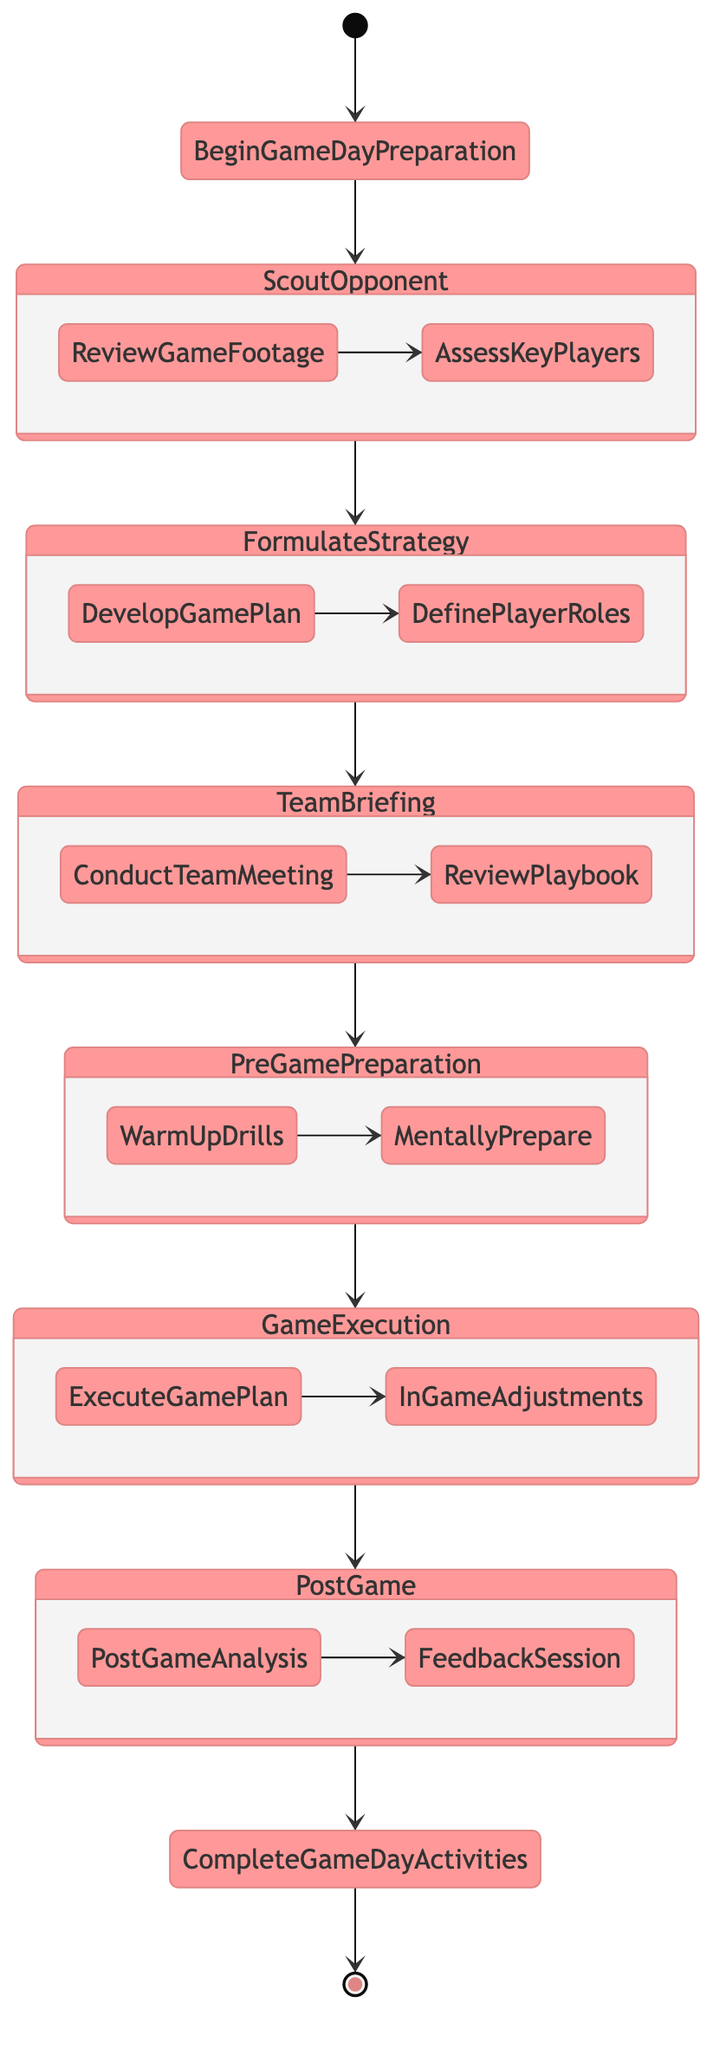What is the first stage of the game day preparation? The diagram starts with the node labeled "Begin Game Day Preparation," which indicates the first stage of the workflow. Thus, the first stage that follows is "Scout Opponent."
Answer: Scout Opponent How many preparation stages are there in total? The diagram outlines four preparation stages: "Scout Opponent," "Formulate Strategy," "Team Briefing," and "Pre-game Preparation." Counting these, we find there are a total of four stages.
Answer: 4 What step comes after "Review Game Footage"? Following the "Review Game Footage" step within the "Scout Opponent" state, the diagram leads to the next step labeled "Assess Key Players." Therefore, this step directly follows it.
Answer: Assess Key Players What is the final activity listed in the post-game section? In the "Post Game" section of the diagram, the last activity before completing all game day activities is "Feedback Session." Hence, this is the final activity.
Answer: Feedback Session What are the two main activities in the Game Execution phase? The "Game Execution" phase contains two key activities as per the diagram: "Execute Game Plan" and "In-Game Adjustments." Both are critical actions within this phase.
Answer: Execute Game Plan, In-Game Adjustments What is the main purpose of the "Team Briefing" stage? The "Team Briefing" stage consists of discussing the game plan and ensuring all players understand the strategies. The goal is to prepare the team collectively, making sure everyone is aligned.
Answer: Discuss game plan and review strategies At which point does the game day preparation transition to the game execution? The transition from preparation to game execution occurs after the "Pre-game Preparation" stage ends, leading directly to the "Game Execution" phase in the diagram.
Answer: After Pre-game Preparation What happens after the "Feedback Session"? The activity that follows the "Feedback Session" as indicated in the diagram is the completion of all game day activities, culminating the preparation and execution workflow for the game.
Answer: Complete Game Day Activities 